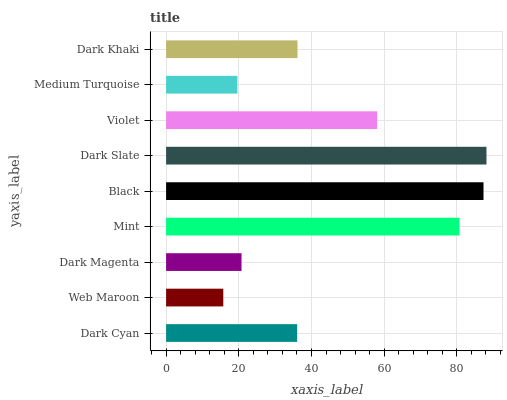Is Web Maroon the minimum?
Answer yes or no. Yes. Is Dark Slate the maximum?
Answer yes or no. Yes. Is Dark Magenta the minimum?
Answer yes or no. No. Is Dark Magenta the maximum?
Answer yes or no. No. Is Dark Magenta greater than Web Maroon?
Answer yes or no. Yes. Is Web Maroon less than Dark Magenta?
Answer yes or no. Yes. Is Web Maroon greater than Dark Magenta?
Answer yes or no. No. Is Dark Magenta less than Web Maroon?
Answer yes or no. No. Is Dark Khaki the high median?
Answer yes or no. Yes. Is Dark Khaki the low median?
Answer yes or no. Yes. Is Black the high median?
Answer yes or no. No. Is Black the low median?
Answer yes or no. No. 